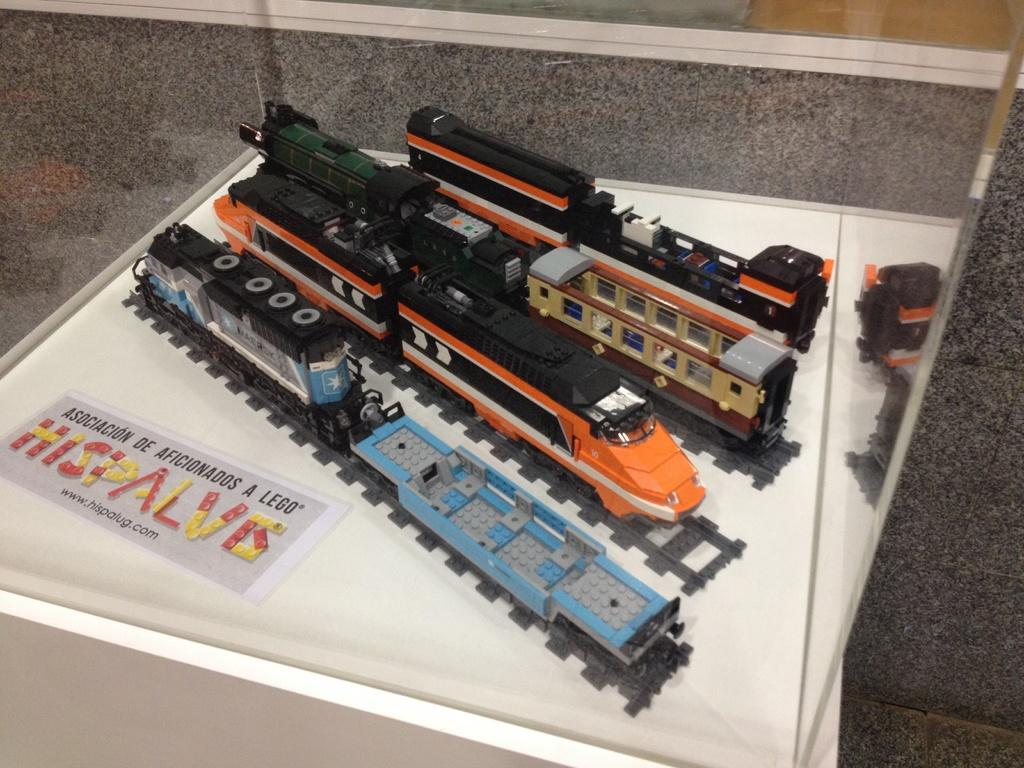What type of toys are in the image? There are toy trains in the image. Where are the toy trains located? The toy trains are in a box. What else can be seen in the image besides the toy trains? There is a poster with text in the image. What type of bone can be seen in the image? There is no bone present in the image; it features toy trains in a box and a poster with text. How many legs are visible in the image? There are no legs visible in the image; it features toy trains in a box and a poster with text. 